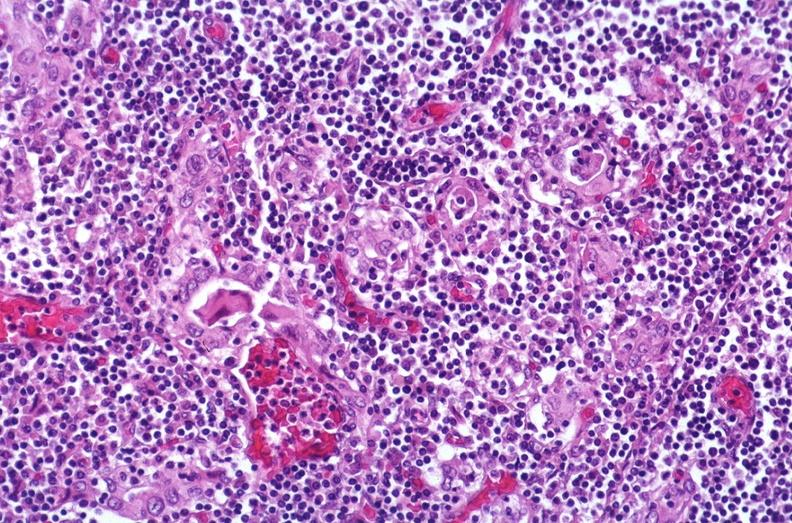what does this image show?
Answer the question using a single word or phrase. Hashimoto 's thyroiditis 